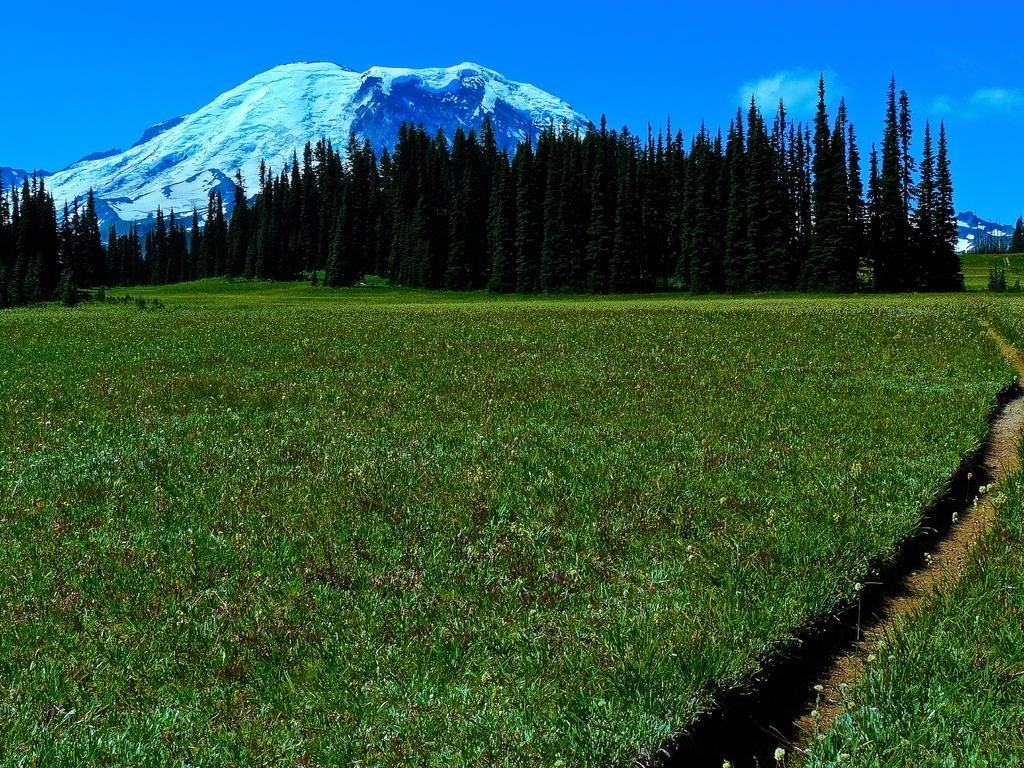What type of vegetation can be seen in the image? There are trees, plants, and grass in the image. What natural features are visible in the background of the image? There are mountains in the background of the image. What is visible in the sky in the image? The sky is visible in the background of the image, and clouds are present. What humorous title can be given to the image? The image does not have a title, and humor is subjective, so it is not possible to provide a humorous title based on the image alone. --- Facts: 1. There is a car in the image. 2. The car is red. 3. The car has four wheels. 4. There is a road in the image. 5. The road is paved. Absurd Topics: ocean, parrot, dance Conversation: What type of vehicle is in the image? There is a car in the image. What color is the car? The car is red. How many wheels does the car have? The car has four wheels. What type of surface is visible in the image? There is a road in the image, and it is paved. Reasoning: Let's think step by step in order to produce the conversation. We start by identifying the main subject in the image, which is the car. Then, we expand the conversation to include other details about the car, such as its color and the number of wheels. Finally, we describe the road visible in the image, noting that it is paved. Absurd Question/Answer: Can you see any parrots dancing on the car in the image? There are no parrots or dancing depicted in the image; it features a red car on a paved road. 